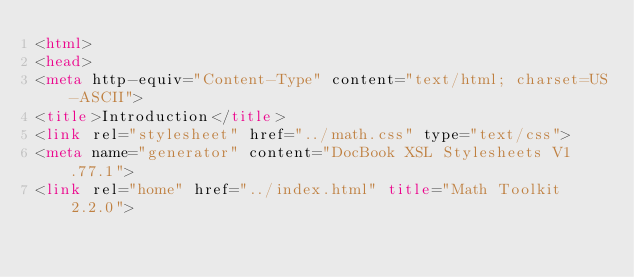Convert code to text. <code><loc_0><loc_0><loc_500><loc_500><_HTML_><html>
<head>
<meta http-equiv="Content-Type" content="text/html; charset=US-ASCII">
<title>Introduction</title>
<link rel="stylesheet" href="../math.css" type="text/css">
<meta name="generator" content="DocBook XSL Stylesheets V1.77.1">
<link rel="home" href="../index.html" title="Math Toolkit 2.2.0"></code> 